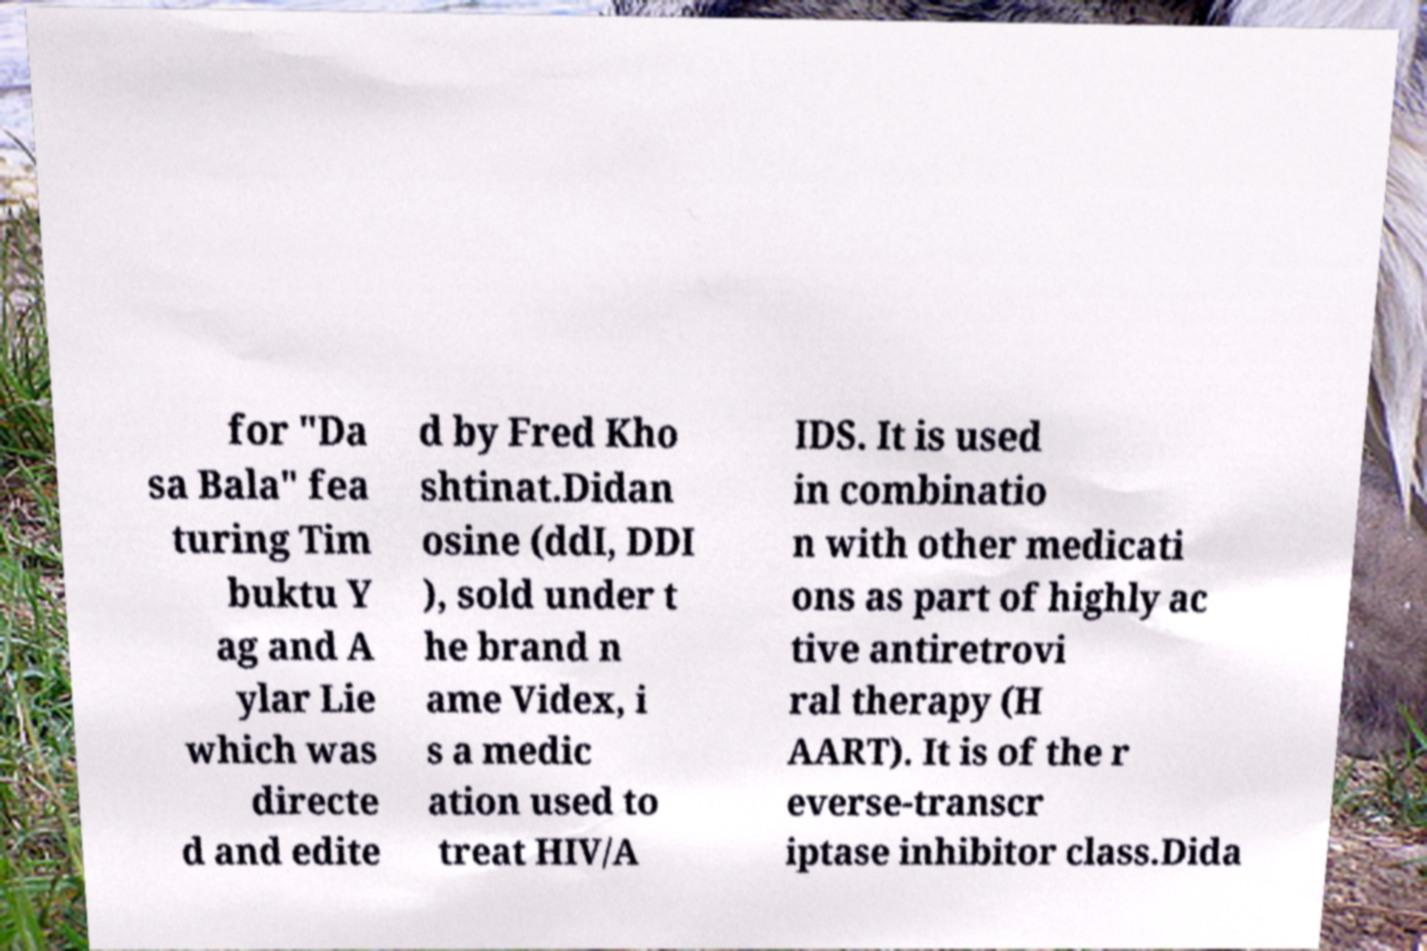For documentation purposes, I need the text within this image transcribed. Could you provide that? for "Da sa Bala" fea turing Tim buktu Y ag and A ylar Lie which was directe d and edite d by Fred Kho shtinat.Didan osine (ddI, DDI ), sold under t he brand n ame Videx, i s a medic ation used to treat HIV/A IDS. It is used in combinatio n with other medicati ons as part of highly ac tive antiretrovi ral therapy (H AART). It is of the r everse-transcr iptase inhibitor class.Dida 